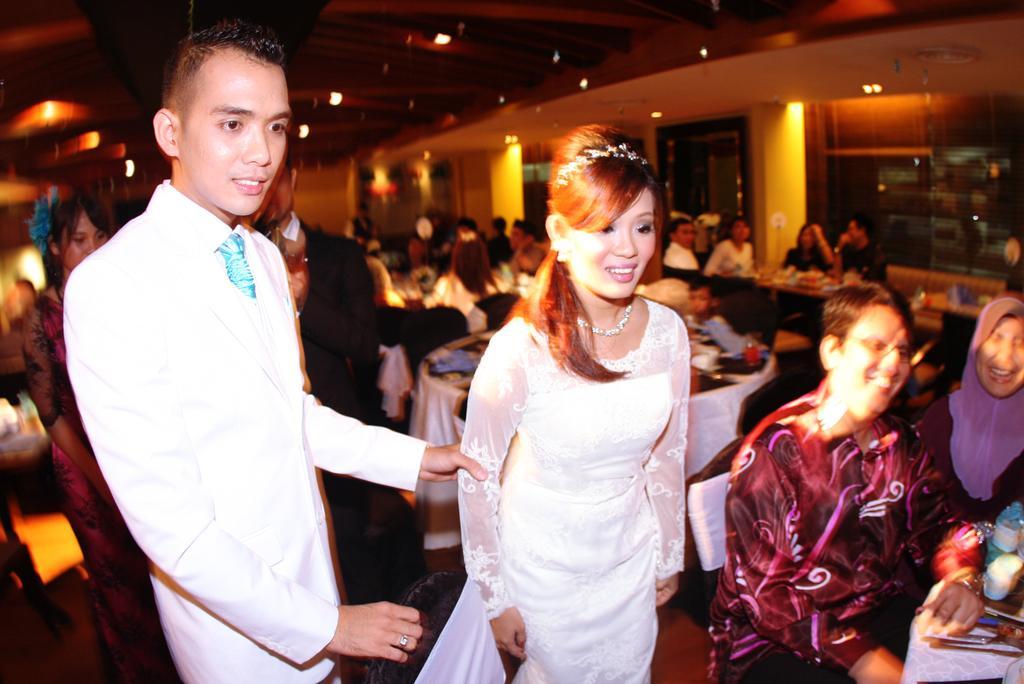Describe this image in one or two sentences. This picture shows a man and woman standing both of them white color dress and we see few people standing on the back and we see group of people seated on the chairs and we see tables and roof lights and we see smile on their faces. 